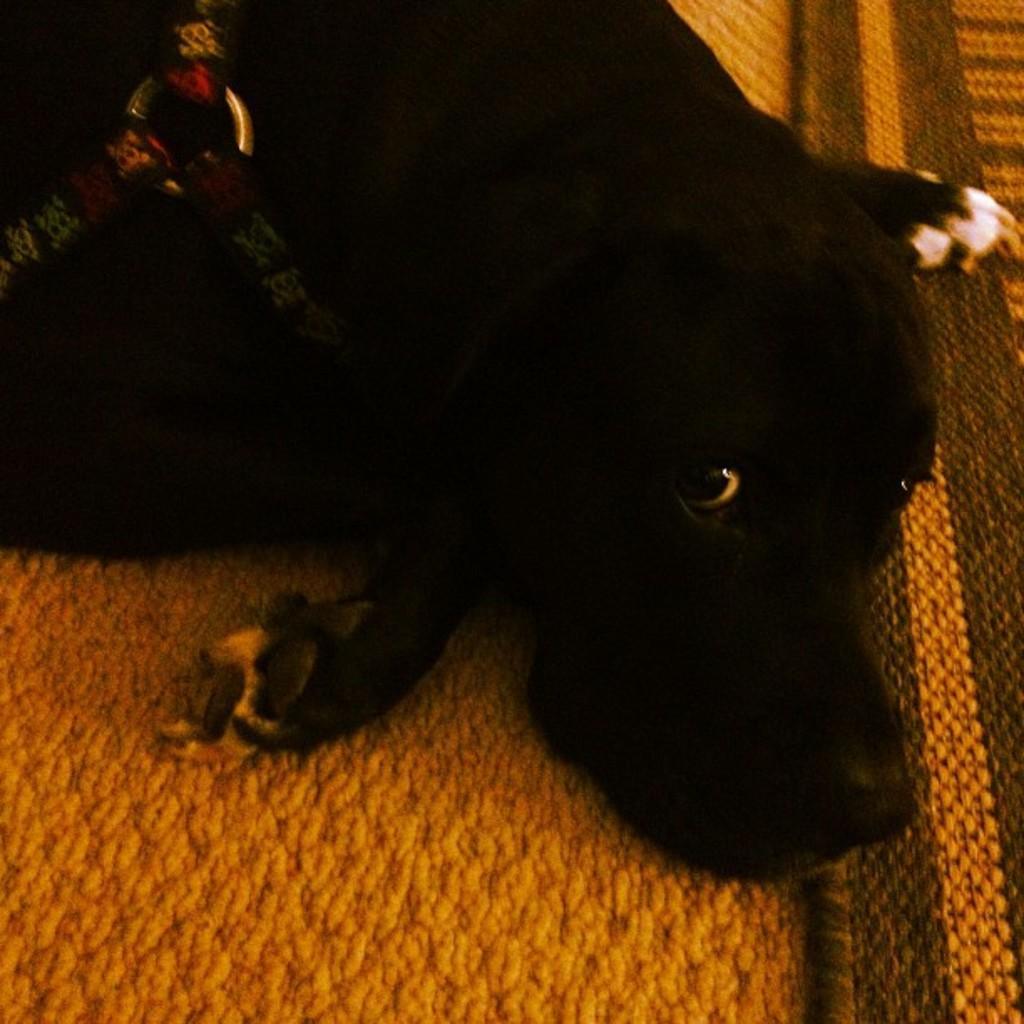What type of animal is present in the image? There is a dog in the image. What color is the dog? The dog is black in color. Where is the dog located in the image? The dog is lying on a carpet. What color is the carpet? The carpet is orange in color. Can you tell me how many rings the dog's aunt is wearing in the image? There is no mention of rings, an aunt, or any other people in the image; it only features a black dog lying on an orange carpet. 